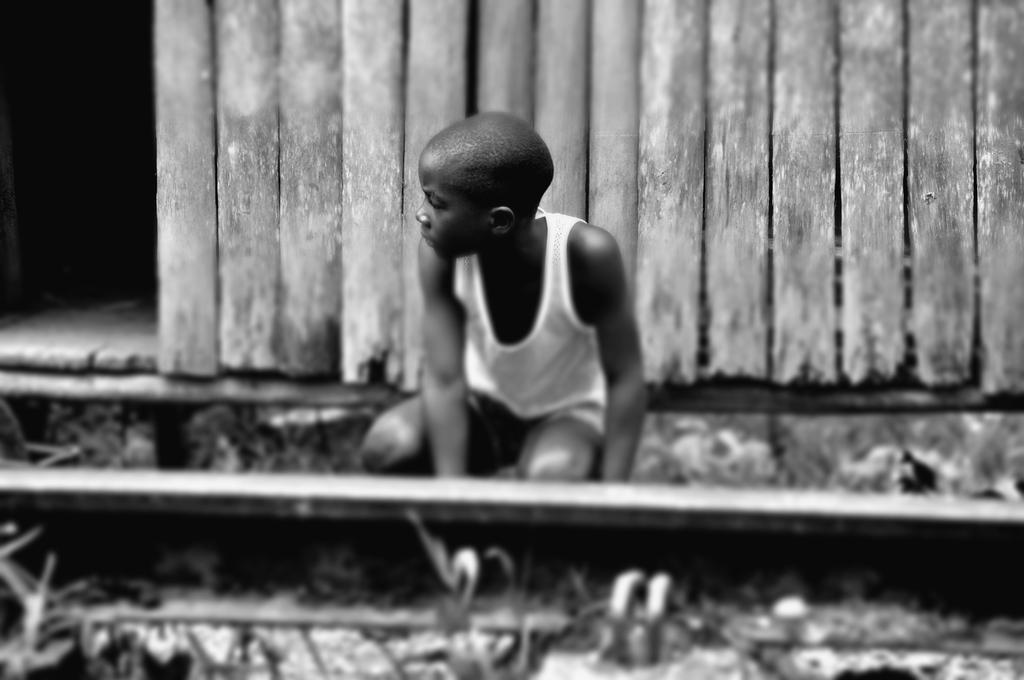What is the color scheme of the image? The image is black and white. What can be seen running through the image? There is a railway track in the image. Who is present in the image? There is a boy in the image. What type of structure is visible in the background of the image? There is a wooden wall in the background of the image. What type of jewel is the boy wearing in the image? There is no mention of a jewel in the image, and the boy is not wearing any jewelry. What color is the silver object in the image? There is no silver object present in the image. 